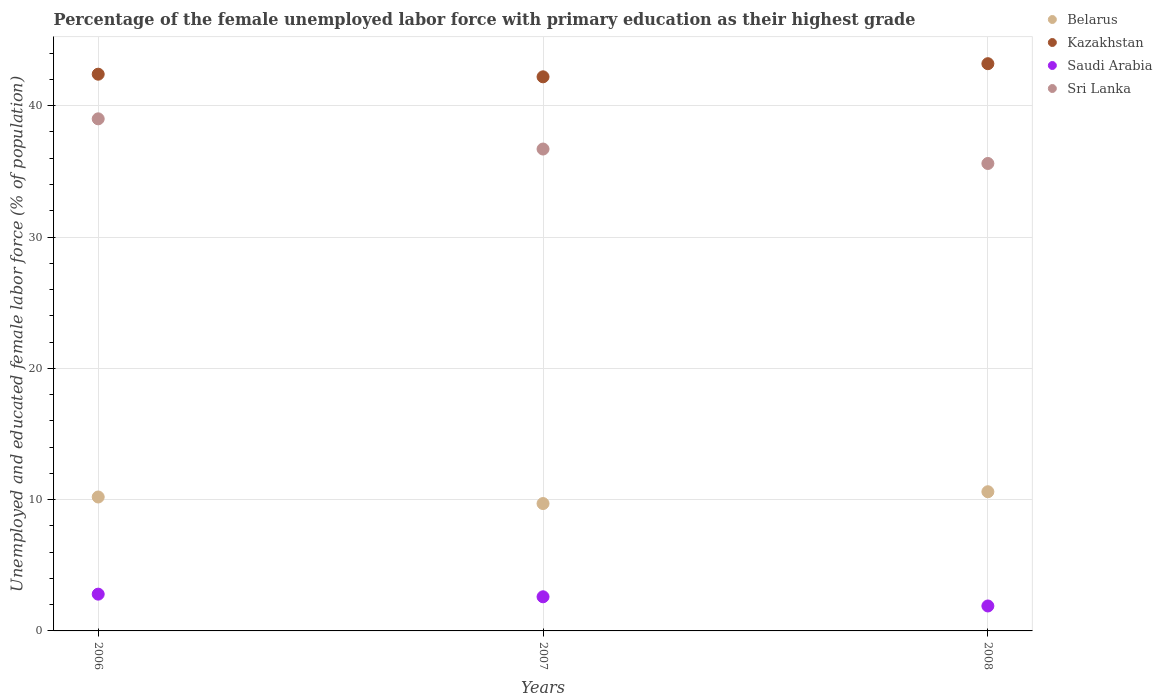What is the percentage of the unemployed female labor force with primary education in Belarus in 2008?
Your answer should be very brief. 10.6. Across all years, what is the maximum percentage of the unemployed female labor force with primary education in Saudi Arabia?
Your response must be concise. 2.8. Across all years, what is the minimum percentage of the unemployed female labor force with primary education in Kazakhstan?
Make the answer very short. 42.2. In which year was the percentage of the unemployed female labor force with primary education in Saudi Arabia minimum?
Give a very brief answer. 2008. What is the total percentage of the unemployed female labor force with primary education in Belarus in the graph?
Your answer should be compact. 30.5. What is the difference between the percentage of the unemployed female labor force with primary education in Saudi Arabia in 2007 and that in 2008?
Offer a very short reply. 0.7. What is the difference between the percentage of the unemployed female labor force with primary education in Saudi Arabia in 2006 and the percentage of the unemployed female labor force with primary education in Belarus in 2008?
Offer a terse response. -7.8. What is the average percentage of the unemployed female labor force with primary education in Belarus per year?
Ensure brevity in your answer.  10.17. In the year 2007, what is the difference between the percentage of the unemployed female labor force with primary education in Belarus and percentage of the unemployed female labor force with primary education in Sri Lanka?
Your response must be concise. -27. What is the ratio of the percentage of the unemployed female labor force with primary education in Kazakhstan in 2006 to that in 2007?
Give a very brief answer. 1. Is the difference between the percentage of the unemployed female labor force with primary education in Belarus in 2006 and 2007 greater than the difference between the percentage of the unemployed female labor force with primary education in Sri Lanka in 2006 and 2007?
Provide a short and direct response. No. What is the difference between the highest and the second highest percentage of the unemployed female labor force with primary education in Sri Lanka?
Keep it short and to the point. 2.3. What is the difference between the highest and the lowest percentage of the unemployed female labor force with primary education in Saudi Arabia?
Ensure brevity in your answer.  0.9. Is the sum of the percentage of the unemployed female labor force with primary education in Saudi Arabia in 2006 and 2007 greater than the maximum percentage of the unemployed female labor force with primary education in Kazakhstan across all years?
Provide a succinct answer. No. Is it the case that in every year, the sum of the percentage of the unemployed female labor force with primary education in Kazakhstan and percentage of the unemployed female labor force with primary education in Belarus  is greater than the percentage of the unemployed female labor force with primary education in Saudi Arabia?
Provide a succinct answer. Yes. Is the percentage of the unemployed female labor force with primary education in Kazakhstan strictly greater than the percentage of the unemployed female labor force with primary education in Sri Lanka over the years?
Keep it short and to the point. Yes. How many dotlines are there?
Provide a short and direct response. 4. What is the difference between two consecutive major ticks on the Y-axis?
Your response must be concise. 10. Are the values on the major ticks of Y-axis written in scientific E-notation?
Your answer should be very brief. No. What is the title of the graph?
Offer a very short reply. Percentage of the female unemployed labor force with primary education as their highest grade. What is the label or title of the Y-axis?
Your answer should be very brief. Unemployed and educated female labor force (% of population). What is the Unemployed and educated female labor force (% of population) of Belarus in 2006?
Offer a very short reply. 10.2. What is the Unemployed and educated female labor force (% of population) of Kazakhstan in 2006?
Ensure brevity in your answer.  42.4. What is the Unemployed and educated female labor force (% of population) of Saudi Arabia in 2006?
Offer a very short reply. 2.8. What is the Unemployed and educated female labor force (% of population) of Sri Lanka in 2006?
Provide a short and direct response. 39. What is the Unemployed and educated female labor force (% of population) in Belarus in 2007?
Offer a very short reply. 9.7. What is the Unemployed and educated female labor force (% of population) in Kazakhstan in 2007?
Make the answer very short. 42.2. What is the Unemployed and educated female labor force (% of population) in Saudi Arabia in 2007?
Your answer should be compact. 2.6. What is the Unemployed and educated female labor force (% of population) of Sri Lanka in 2007?
Offer a very short reply. 36.7. What is the Unemployed and educated female labor force (% of population) in Belarus in 2008?
Your answer should be compact. 10.6. What is the Unemployed and educated female labor force (% of population) in Kazakhstan in 2008?
Make the answer very short. 43.2. What is the Unemployed and educated female labor force (% of population) in Saudi Arabia in 2008?
Provide a short and direct response. 1.9. What is the Unemployed and educated female labor force (% of population) in Sri Lanka in 2008?
Make the answer very short. 35.6. Across all years, what is the maximum Unemployed and educated female labor force (% of population) of Belarus?
Provide a succinct answer. 10.6. Across all years, what is the maximum Unemployed and educated female labor force (% of population) of Kazakhstan?
Offer a very short reply. 43.2. Across all years, what is the maximum Unemployed and educated female labor force (% of population) in Saudi Arabia?
Provide a succinct answer. 2.8. Across all years, what is the minimum Unemployed and educated female labor force (% of population) in Belarus?
Your answer should be very brief. 9.7. Across all years, what is the minimum Unemployed and educated female labor force (% of population) in Kazakhstan?
Give a very brief answer. 42.2. Across all years, what is the minimum Unemployed and educated female labor force (% of population) of Saudi Arabia?
Keep it short and to the point. 1.9. Across all years, what is the minimum Unemployed and educated female labor force (% of population) in Sri Lanka?
Your answer should be very brief. 35.6. What is the total Unemployed and educated female labor force (% of population) in Belarus in the graph?
Give a very brief answer. 30.5. What is the total Unemployed and educated female labor force (% of population) of Kazakhstan in the graph?
Your answer should be very brief. 127.8. What is the total Unemployed and educated female labor force (% of population) of Sri Lanka in the graph?
Give a very brief answer. 111.3. What is the difference between the Unemployed and educated female labor force (% of population) of Kazakhstan in 2006 and that in 2007?
Provide a succinct answer. 0.2. What is the difference between the Unemployed and educated female labor force (% of population) in Saudi Arabia in 2006 and that in 2007?
Give a very brief answer. 0.2. What is the difference between the Unemployed and educated female labor force (% of population) of Sri Lanka in 2006 and that in 2007?
Your answer should be very brief. 2.3. What is the difference between the Unemployed and educated female labor force (% of population) in Belarus in 2006 and that in 2008?
Ensure brevity in your answer.  -0.4. What is the difference between the Unemployed and educated female labor force (% of population) in Kazakhstan in 2006 and that in 2008?
Your answer should be very brief. -0.8. What is the difference between the Unemployed and educated female labor force (% of population) of Saudi Arabia in 2006 and that in 2008?
Your response must be concise. 0.9. What is the difference between the Unemployed and educated female labor force (% of population) in Belarus in 2007 and that in 2008?
Offer a very short reply. -0.9. What is the difference between the Unemployed and educated female labor force (% of population) in Saudi Arabia in 2007 and that in 2008?
Provide a succinct answer. 0.7. What is the difference between the Unemployed and educated female labor force (% of population) in Belarus in 2006 and the Unemployed and educated female labor force (% of population) in Kazakhstan in 2007?
Provide a succinct answer. -32. What is the difference between the Unemployed and educated female labor force (% of population) in Belarus in 2006 and the Unemployed and educated female labor force (% of population) in Saudi Arabia in 2007?
Your answer should be compact. 7.6. What is the difference between the Unemployed and educated female labor force (% of population) of Belarus in 2006 and the Unemployed and educated female labor force (% of population) of Sri Lanka in 2007?
Give a very brief answer. -26.5. What is the difference between the Unemployed and educated female labor force (% of population) of Kazakhstan in 2006 and the Unemployed and educated female labor force (% of population) of Saudi Arabia in 2007?
Ensure brevity in your answer.  39.8. What is the difference between the Unemployed and educated female labor force (% of population) in Kazakhstan in 2006 and the Unemployed and educated female labor force (% of population) in Sri Lanka in 2007?
Provide a short and direct response. 5.7. What is the difference between the Unemployed and educated female labor force (% of population) of Saudi Arabia in 2006 and the Unemployed and educated female labor force (% of population) of Sri Lanka in 2007?
Your answer should be very brief. -33.9. What is the difference between the Unemployed and educated female labor force (% of population) of Belarus in 2006 and the Unemployed and educated female labor force (% of population) of Kazakhstan in 2008?
Your answer should be very brief. -33. What is the difference between the Unemployed and educated female labor force (% of population) in Belarus in 2006 and the Unemployed and educated female labor force (% of population) in Sri Lanka in 2008?
Your answer should be very brief. -25.4. What is the difference between the Unemployed and educated female labor force (% of population) of Kazakhstan in 2006 and the Unemployed and educated female labor force (% of population) of Saudi Arabia in 2008?
Offer a very short reply. 40.5. What is the difference between the Unemployed and educated female labor force (% of population) in Saudi Arabia in 2006 and the Unemployed and educated female labor force (% of population) in Sri Lanka in 2008?
Offer a very short reply. -32.8. What is the difference between the Unemployed and educated female labor force (% of population) in Belarus in 2007 and the Unemployed and educated female labor force (% of population) in Kazakhstan in 2008?
Keep it short and to the point. -33.5. What is the difference between the Unemployed and educated female labor force (% of population) of Belarus in 2007 and the Unemployed and educated female labor force (% of population) of Saudi Arabia in 2008?
Offer a terse response. 7.8. What is the difference between the Unemployed and educated female labor force (% of population) of Belarus in 2007 and the Unemployed and educated female labor force (% of population) of Sri Lanka in 2008?
Your response must be concise. -25.9. What is the difference between the Unemployed and educated female labor force (% of population) in Kazakhstan in 2007 and the Unemployed and educated female labor force (% of population) in Saudi Arabia in 2008?
Keep it short and to the point. 40.3. What is the difference between the Unemployed and educated female labor force (% of population) of Saudi Arabia in 2007 and the Unemployed and educated female labor force (% of population) of Sri Lanka in 2008?
Provide a short and direct response. -33. What is the average Unemployed and educated female labor force (% of population) of Belarus per year?
Provide a succinct answer. 10.17. What is the average Unemployed and educated female labor force (% of population) of Kazakhstan per year?
Offer a terse response. 42.6. What is the average Unemployed and educated female labor force (% of population) in Saudi Arabia per year?
Offer a very short reply. 2.43. What is the average Unemployed and educated female labor force (% of population) in Sri Lanka per year?
Your answer should be very brief. 37.1. In the year 2006, what is the difference between the Unemployed and educated female labor force (% of population) in Belarus and Unemployed and educated female labor force (% of population) in Kazakhstan?
Keep it short and to the point. -32.2. In the year 2006, what is the difference between the Unemployed and educated female labor force (% of population) of Belarus and Unemployed and educated female labor force (% of population) of Sri Lanka?
Provide a succinct answer. -28.8. In the year 2006, what is the difference between the Unemployed and educated female labor force (% of population) in Kazakhstan and Unemployed and educated female labor force (% of population) in Saudi Arabia?
Ensure brevity in your answer.  39.6. In the year 2006, what is the difference between the Unemployed and educated female labor force (% of population) in Saudi Arabia and Unemployed and educated female labor force (% of population) in Sri Lanka?
Your answer should be very brief. -36.2. In the year 2007, what is the difference between the Unemployed and educated female labor force (% of population) of Belarus and Unemployed and educated female labor force (% of population) of Kazakhstan?
Offer a very short reply. -32.5. In the year 2007, what is the difference between the Unemployed and educated female labor force (% of population) in Belarus and Unemployed and educated female labor force (% of population) in Sri Lanka?
Offer a terse response. -27. In the year 2007, what is the difference between the Unemployed and educated female labor force (% of population) in Kazakhstan and Unemployed and educated female labor force (% of population) in Saudi Arabia?
Your response must be concise. 39.6. In the year 2007, what is the difference between the Unemployed and educated female labor force (% of population) of Saudi Arabia and Unemployed and educated female labor force (% of population) of Sri Lanka?
Offer a terse response. -34.1. In the year 2008, what is the difference between the Unemployed and educated female labor force (% of population) of Belarus and Unemployed and educated female labor force (% of population) of Kazakhstan?
Offer a very short reply. -32.6. In the year 2008, what is the difference between the Unemployed and educated female labor force (% of population) in Kazakhstan and Unemployed and educated female labor force (% of population) in Saudi Arabia?
Your answer should be compact. 41.3. In the year 2008, what is the difference between the Unemployed and educated female labor force (% of population) in Saudi Arabia and Unemployed and educated female labor force (% of population) in Sri Lanka?
Provide a succinct answer. -33.7. What is the ratio of the Unemployed and educated female labor force (% of population) in Belarus in 2006 to that in 2007?
Keep it short and to the point. 1.05. What is the ratio of the Unemployed and educated female labor force (% of population) of Sri Lanka in 2006 to that in 2007?
Offer a very short reply. 1.06. What is the ratio of the Unemployed and educated female labor force (% of population) in Belarus in 2006 to that in 2008?
Keep it short and to the point. 0.96. What is the ratio of the Unemployed and educated female labor force (% of population) in Kazakhstan in 2006 to that in 2008?
Provide a succinct answer. 0.98. What is the ratio of the Unemployed and educated female labor force (% of population) of Saudi Arabia in 2006 to that in 2008?
Make the answer very short. 1.47. What is the ratio of the Unemployed and educated female labor force (% of population) of Sri Lanka in 2006 to that in 2008?
Your answer should be very brief. 1.1. What is the ratio of the Unemployed and educated female labor force (% of population) in Belarus in 2007 to that in 2008?
Your answer should be compact. 0.92. What is the ratio of the Unemployed and educated female labor force (% of population) of Kazakhstan in 2007 to that in 2008?
Your answer should be compact. 0.98. What is the ratio of the Unemployed and educated female labor force (% of population) in Saudi Arabia in 2007 to that in 2008?
Your response must be concise. 1.37. What is the ratio of the Unemployed and educated female labor force (% of population) of Sri Lanka in 2007 to that in 2008?
Keep it short and to the point. 1.03. What is the difference between the highest and the second highest Unemployed and educated female labor force (% of population) of Belarus?
Your answer should be very brief. 0.4. What is the difference between the highest and the second highest Unemployed and educated female labor force (% of population) of Kazakhstan?
Your answer should be compact. 0.8. What is the difference between the highest and the second highest Unemployed and educated female labor force (% of population) in Saudi Arabia?
Your response must be concise. 0.2. What is the difference between the highest and the lowest Unemployed and educated female labor force (% of population) of Belarus?
Keep it short and to the point. 0.9. What is the difference between the highest and the lowest Unemployed and educated female labor force (% of population) of Kazakhstan?
Give a very brief answer. 1. What is the difference between the highest and the lowest Unemployed and educated female labor force (% of population) in Saudi Arabia?
Keep it short and to the point. 0.9. What is the difference between the highest and the lowest Unemployed and educated female labor force (% of population) in Sri Lanka?
Your answer should be compact. 3.4. 